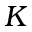<formula> <loc_0><loc_0><loc_500><loc_500>K</formula> 